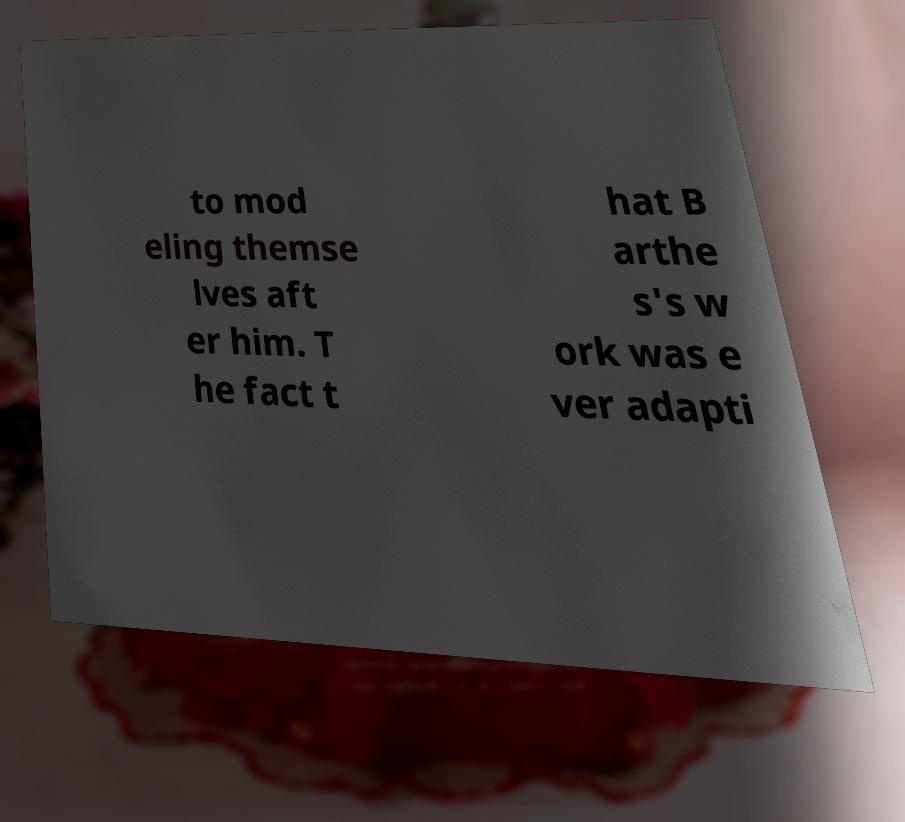There's text embedded in this image that I need extracted. Can you transcribe it verbatim? to mod eling themse lves aft er him. T he fact t hat B arthe s's w ork was e ver adapti 